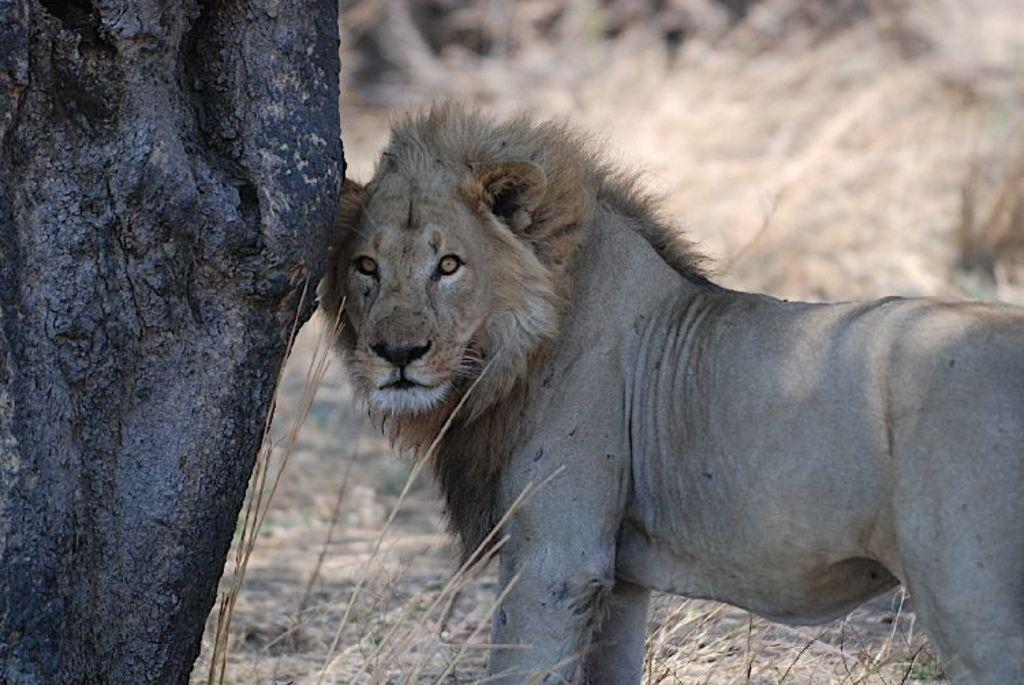What animal is the main subject of the image? There is a lion in the image. Where is the lion positioned in relation to the tree trunk? The lion is standing beside a tree trunk. What type of vegetation can be seen at the bottom of the image? Dry grass is visible at the bottom of the image. How would you describe the background of the image? The background of the image is blurred. What type of toys can be seen scattered around the lion in the image? There are no toys present in the image; it features a lion standing beside a tree trunk. Can you see an island in the background of the image? There is no island visible in the image; the background is blurred. 